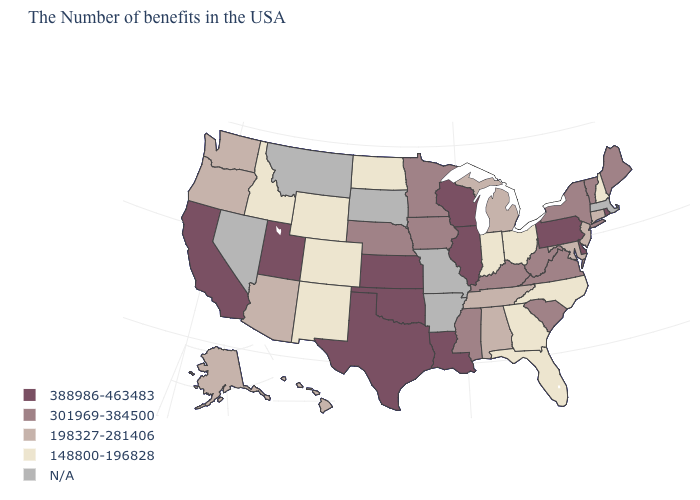What is the highest value in the Northeast ?
Be succinct. 388986-463483. What is the lowest value in the USA?
Write a very short answer. 148800-196828. What is the value of Arkansas?
Short answer required. N/A. Name the states that have a value in the range 148800-196828?
Give a very brief answer. New Hampshire, North Carolina, Ohio, Florida, Georgia, Indiana, North Dakota, Wyoming, Colorado, New Mexico, Idaho. Does the map have missing data?
Write a very short answer. Yes. Does the first symbol in the legend represent the smallest category?
Answer briefly. No. Name the states that have a value in the range 388986-463483?
Answer briefly. Rhode Island, Delaware, Pennsylvania, Wisconsin, Illinois, Louisiana, Kansas, Oklahoma, Texas, Utah, California. What is the value of Nebraska?
Concise answer only. 301969-384500. Is the legend a continuous bar?
Answer briefly. No. What is the lowest value in states that border New Mexico?
Be succinct. 148800-196828. Name the states that have a value in the range 198327-281406?
Short answer required. Connecticut, New Jersey, Maryland, Michigan, Alabama, Tennessee, Arizona, Washington, Oregon, Alaska, Hawaii. What is the value of Colorado?
Short answer required. 148800-196828. Is the legend a continuous bar?
Keep it brief. No. 